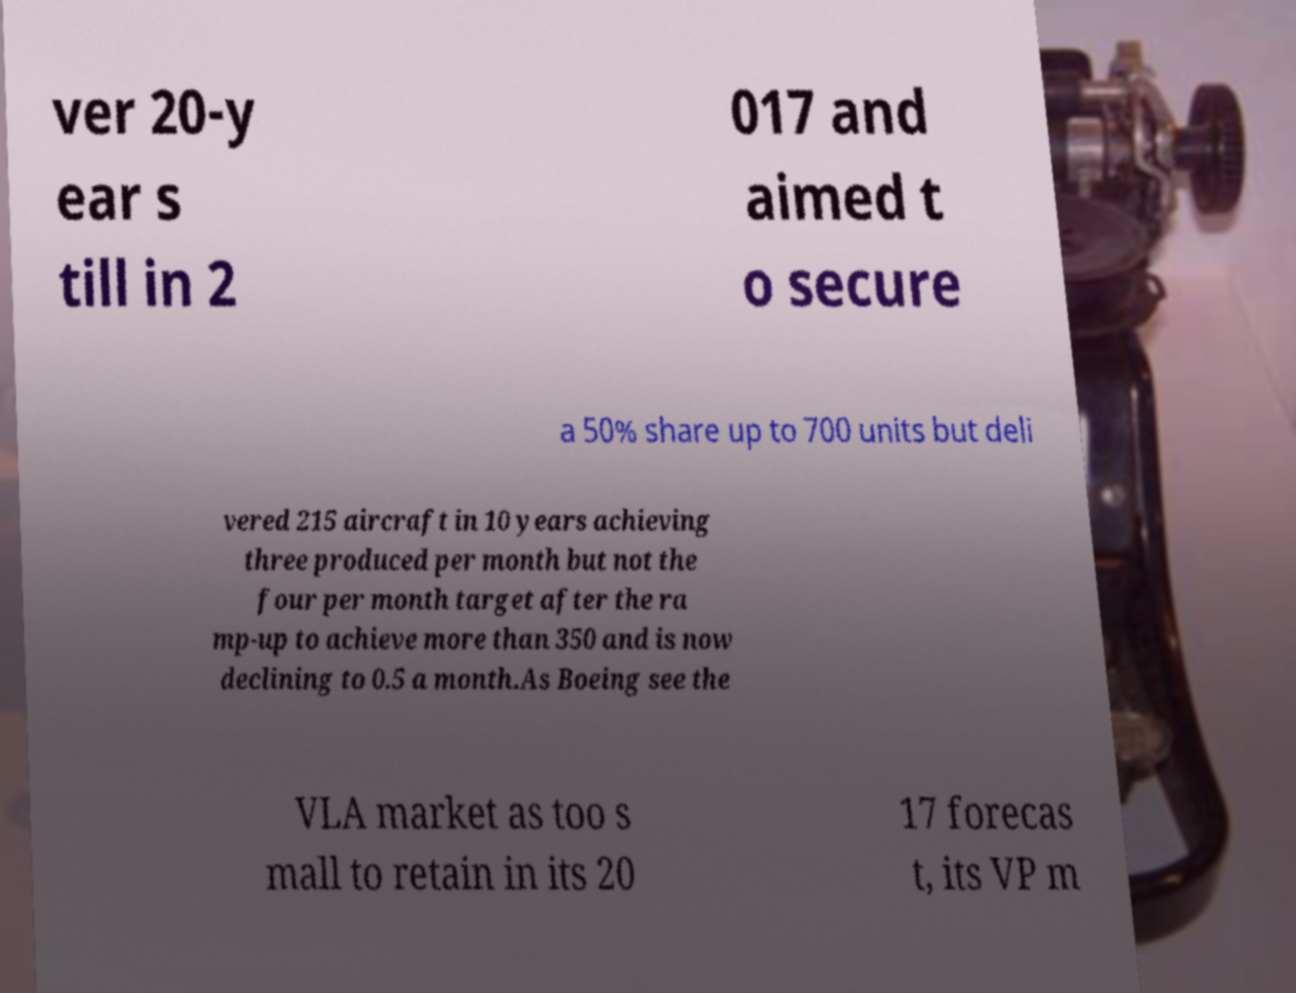Could you assist in decoding the text presented in this image and type it out clearly? ver 20-y ear s till in 2 017 and aimed t o secure a 50% share up to 700 units but deli vered 215 aircraft in 10 years achieving three produced per month but not the four per month target after the ra mp-up to achieve more than 350 and is now declining to 0.5 a month.As Boeing see the VLA market as too s mall to retain in its 20 17 forecas t, its VP m 